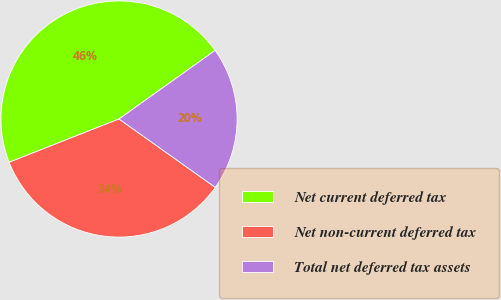Convert chart to OTSL. <chart><loc_0><loc_0><loc_500><loc_500><pie_chart><fcel>Net current deferred tax<fcel>Net non-current deferred tax<fcel>Total net deferred tax assets<nl><fcel>46.11%<fcel>34.2%<fcel>19.69%<nl></chart> 